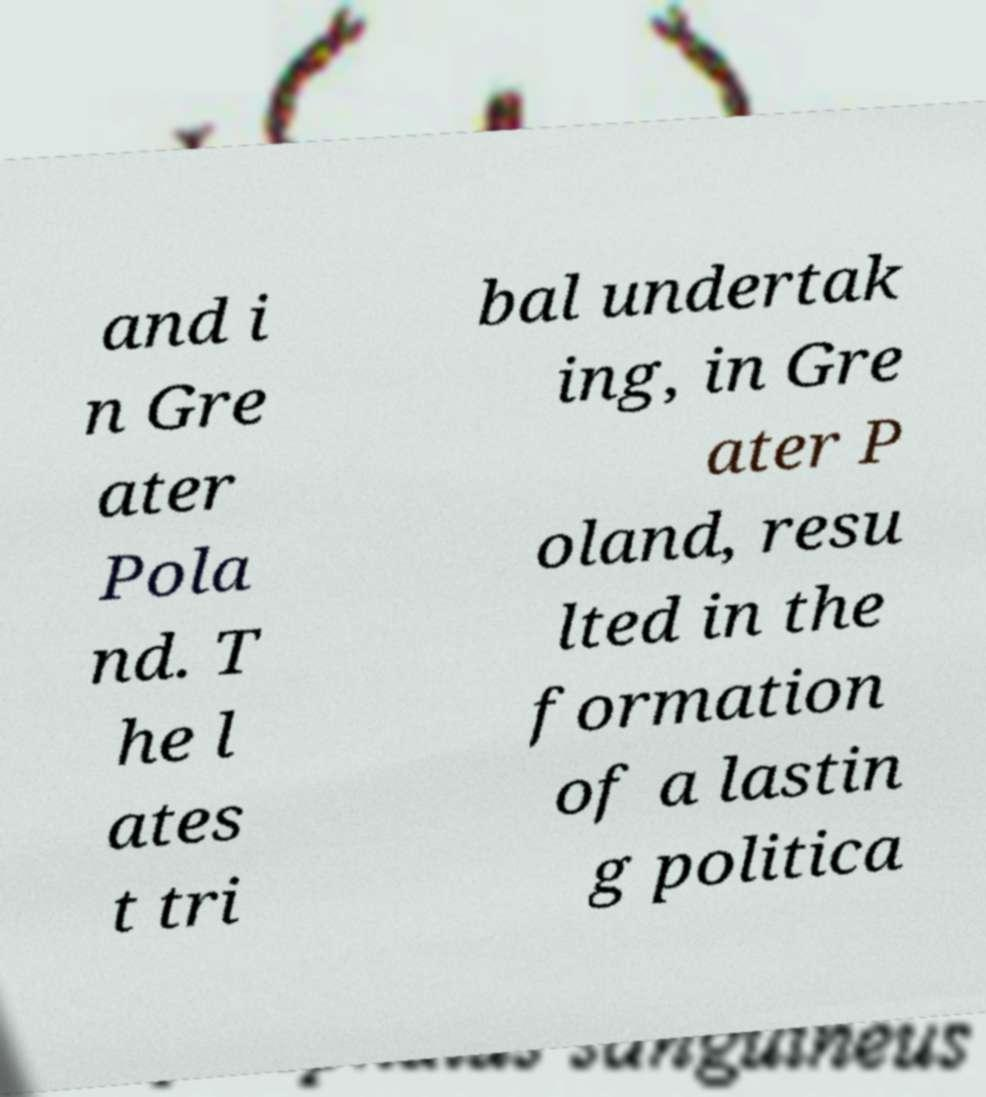Can you accurately transcribe the text from the provided image for me? and i n Gre ater Pola nd. T he l ates t tri bal undertak ing, in Gre ater P oland, resu lted in the formation of a lastin g politica 